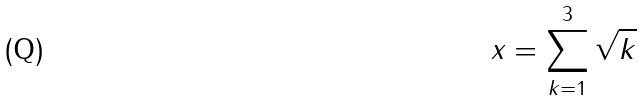Convert formula to latex. <formula><loc_0><loc_0><loc_500><loc_500>x = \sum _ { k = 1 } ^ { 3 } \sqrt { k }</formula> 